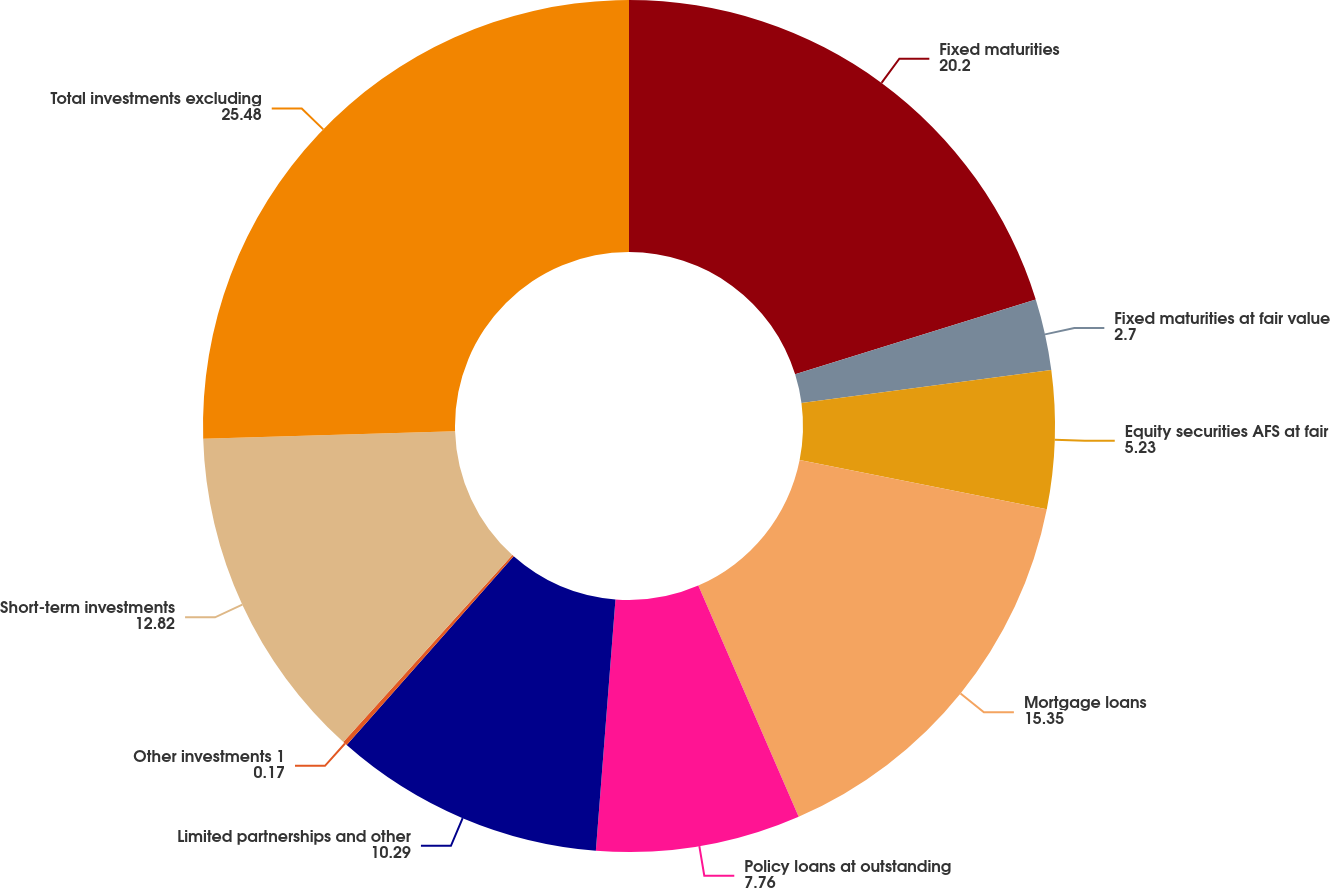<chart> <loc_0><loc_0><loc_500><loc_500><pie_chart><fcel>Fixed maturities<fcel>Fixed maturities at fair value<fcel>Equity securities AFS at fair<fcel>Mortgage loans<fcel>Policy loans at outstanding<fcel>Limited partnerships and other<fcel>Other investments 1<fcel>Short-term investments<fcel>Total investments excluding<nl><fcel>20.2%<fcel>2.7%<fcel>5.23%<fcel>15.35%<fcel>7.76%<fcel>10.29%<fcel>0.17%<fcel>12.82%<fcel>25.48%<nl></chart> 